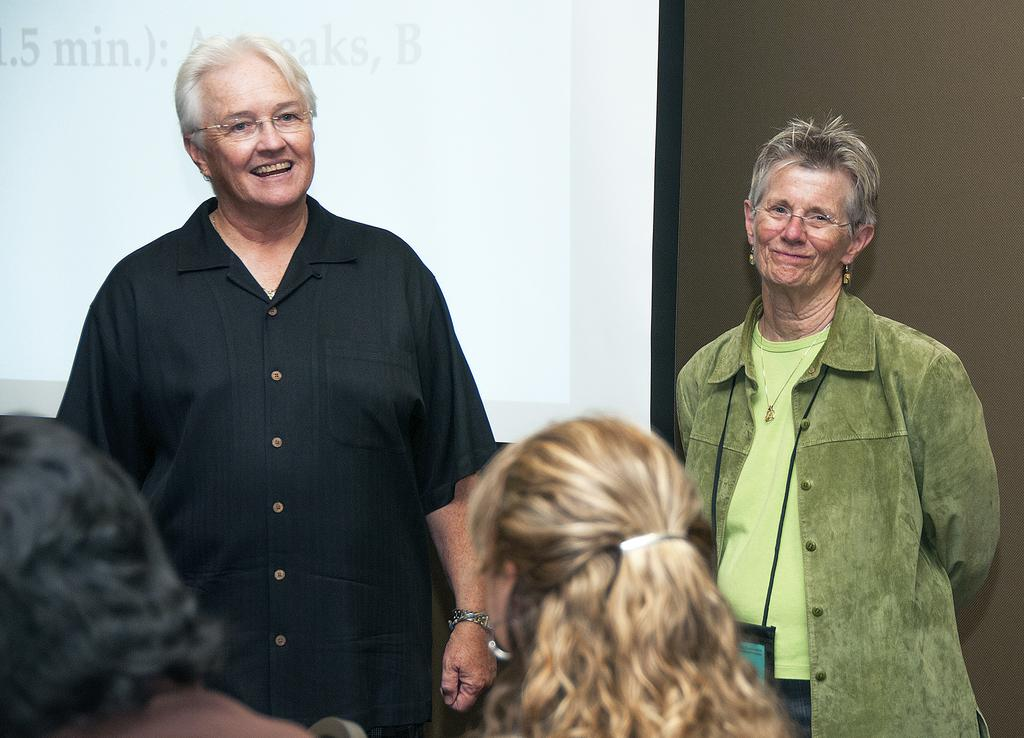Who is present in the middle of the picture? There are women in the middle of the picture. What is located behind the women? There is a projector display screen behind the women. What can be seen in the background of the image? There is a wall visible in the background of the image. Can you see any dogs swimming in the lake in the image? There is no lake or dogs present in the image. 